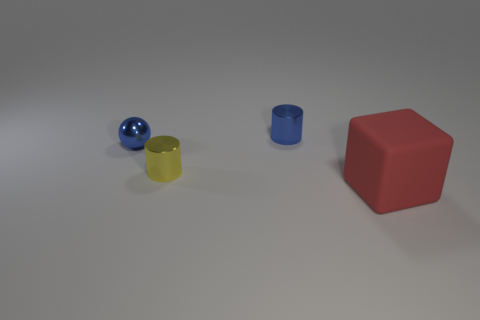There is a yellow shiny thing that is the same size as the blue ball; what shape is it?
Your response must be concise. Cylinder. How many things are either small yellow shiny things or small shiny objects?
Offer a very short reply. 3. Is there a big red metal block?
Your answer should be very brief. No. Are there fewer tiny gray balls than yellow objects?
Make the answer very short. Yes. Are there any cyan metal balls that have the same size as the blue ball?
Offer a terse response. No. There is a large rubber thing; is its shape the same as the object that is behind the blue shiny ball?
Your answer should be compact. No. How many spheres are either red objects or small yellow shiny objects?
Keep it short and to the point. 0. The small ball is what color?
Offer a very short reply. Blue. Are there more green rubber cylinders than small yellow cylinders?
Offer a very short reply. No. What number of things are objects that are on the left side of the large cube or blue cylinders?
Your answer should be very brief. 3. 